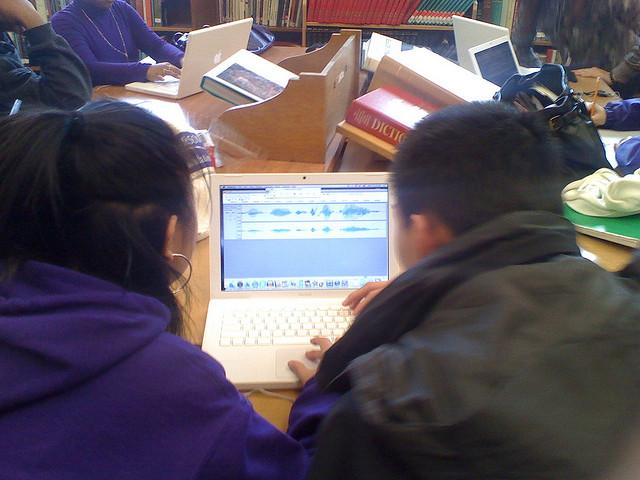Without the computers where would they look up definitions?

Choices:
A) black book
B) green book
C) white book
D) red book red book 